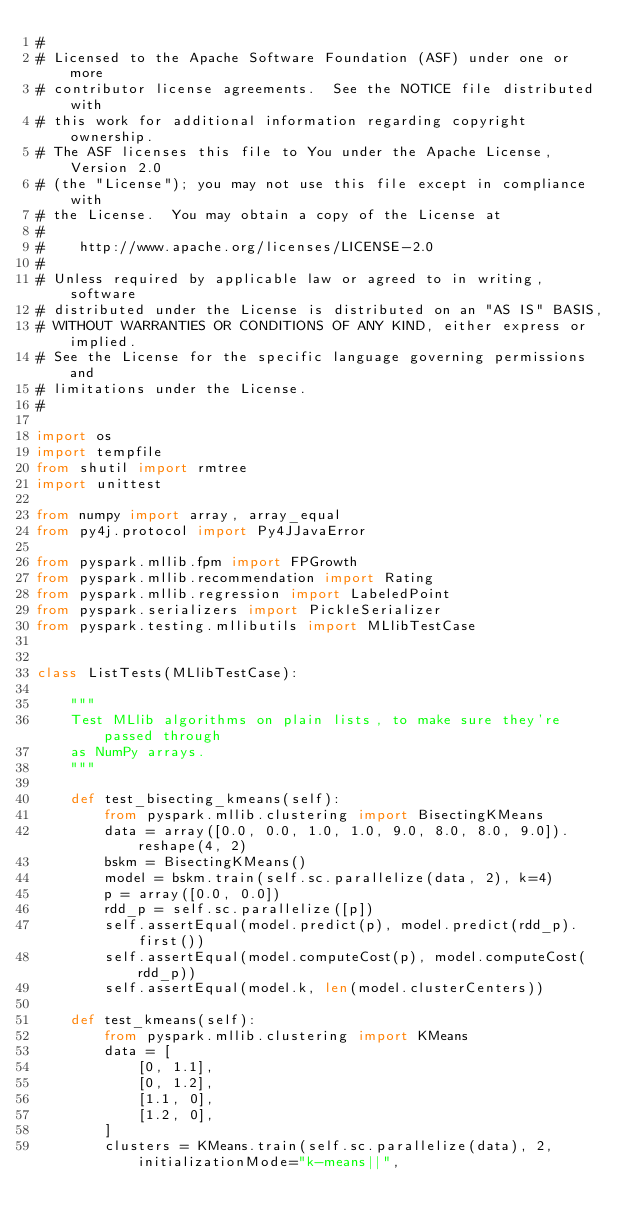<code> <loc_0><loc_0><loc_500><loc_500><_Python_>#
# Licensed to the Apache Software Foundation (ASF) under one or more
# contributor license agreements.  See the NOTICE file distributed with
# this work for additional information regarding copyright ownership.
# The ASF licenses this file to You under the Apache License, Version 2.0
# (the "License"); you may not use this file except in compliance with
# the License.  You may obtain a copy of the License at
#
#    http://www.apache.org/licenses/LICENSE-2.0
#
# Unless required by applicable law or agreed to in writing, software
# distributed under the License is distributed on an "AS IS" BASIS,
# WITHOUT WARRANTIES OR CONDITIONS OF ANY KIND, either express or implied.
# See the License for the specific language governing permissions and
# limitations under the License.
#

import os
import tempfile
from shutil import rmtree
import unittest

from numpy import array, array_equal
from py4j.protocol import Py4JJavaError

from pyspark.mllib.fpm import FPGrowth
from pyspark.mllib.recommendation import Rating
from pyspark.mllib.regression import LabeledPoint
from pyspark.serializers import PickleSerializer
from pyspark.testing.mllibutils import MLlibTestCase


class ListTests(MLlibTestCase):

    """
    Test MLlib algorithms on plain lists, to make sure they're passed through
    as NumPy arrays.
    """

    def test_bisecting_kmeans(self):
        from pyspark.mllib.clustering import BisectingKMeans
        data = array([0.0, 0.0, 1.0, 1.0, 9.0, 8.0, 8.0, 9.0]).reshape(4, 2)
        bskm = BisectingKMeans()
        model = bskm.train(self.sc.parallelize(data, 2), k=4)
        p = array([0.0, 0.0])
        rdd_p = self.sc.parallelize([p])
        self.assertEqual(model.predict(p), model.predict(rdd_p).first())
        self.assertEqual(model.computeCost(p), model.computeCost(rdd_p))
        self.assertEqual(model.k, len(model.clusterCenters))

    def test_kmeans(self):
        from pyspark.mllib.clustering import KMeans
        data = [
            [0, 1.1],
            [0, 1.2],
            [1.1, 0],
            [1.2, 0],
        ]
        clusters = KMeans.train(self.sc.parallelize(data), 2, initializationMode="k-means||",</code> 